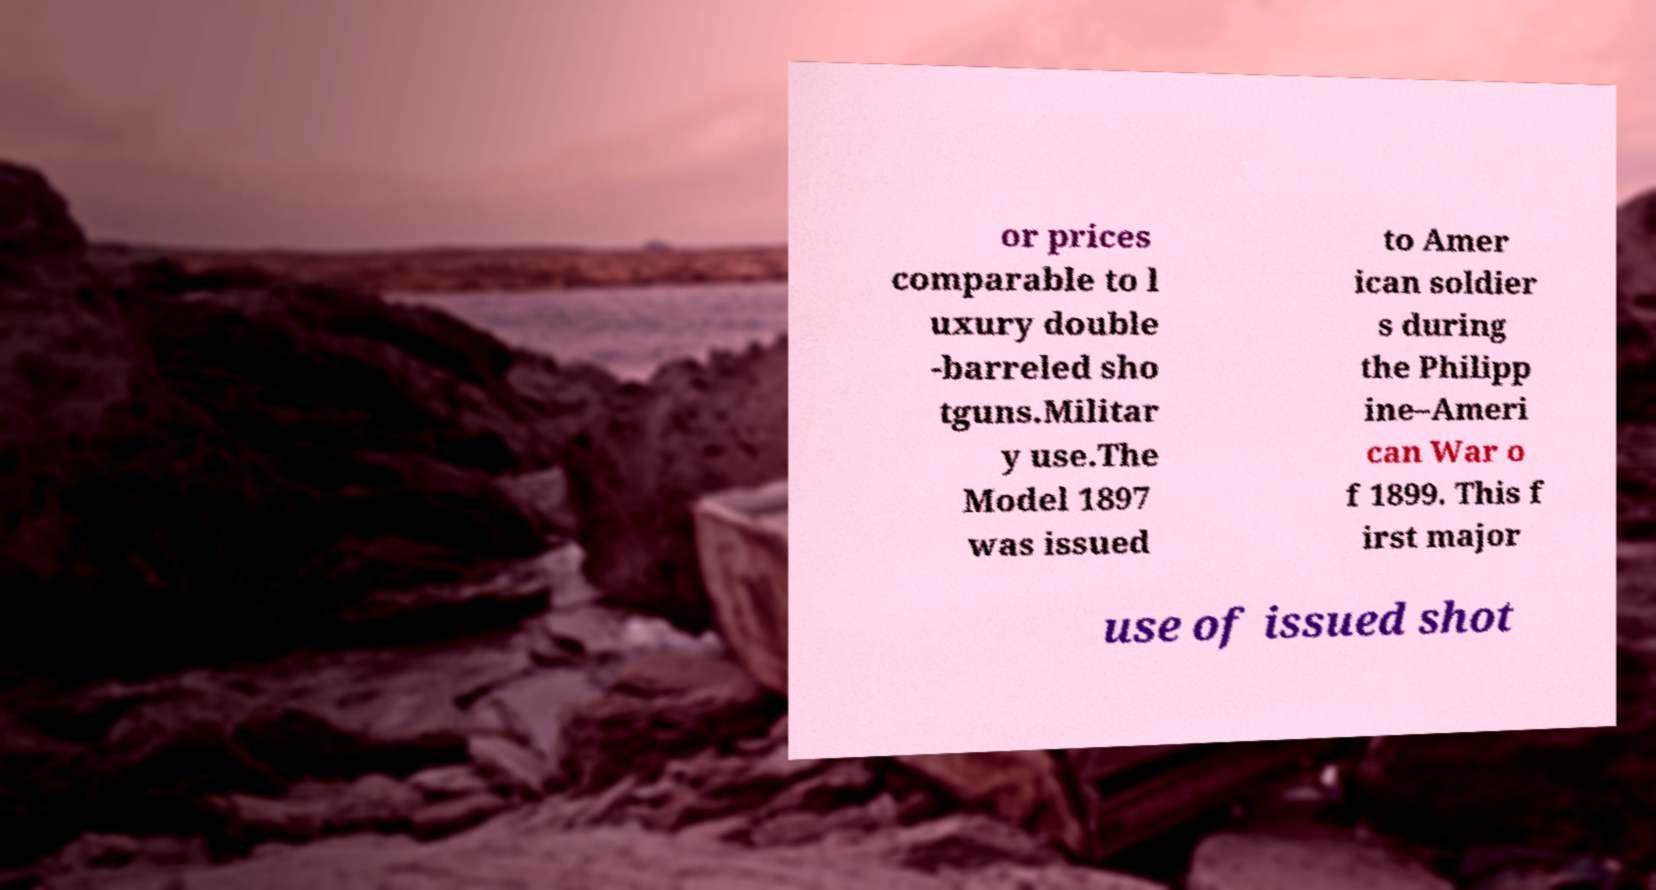Please read and relay the text visible in this image. What does it say? or prices comparable to l uxury double -barreled sho tguns.Militar y use.The Model 1897 was issued to Amer ican soldier s during the Philipp ine–Ameri can War o f 1899. This f irst major use of issued shot 